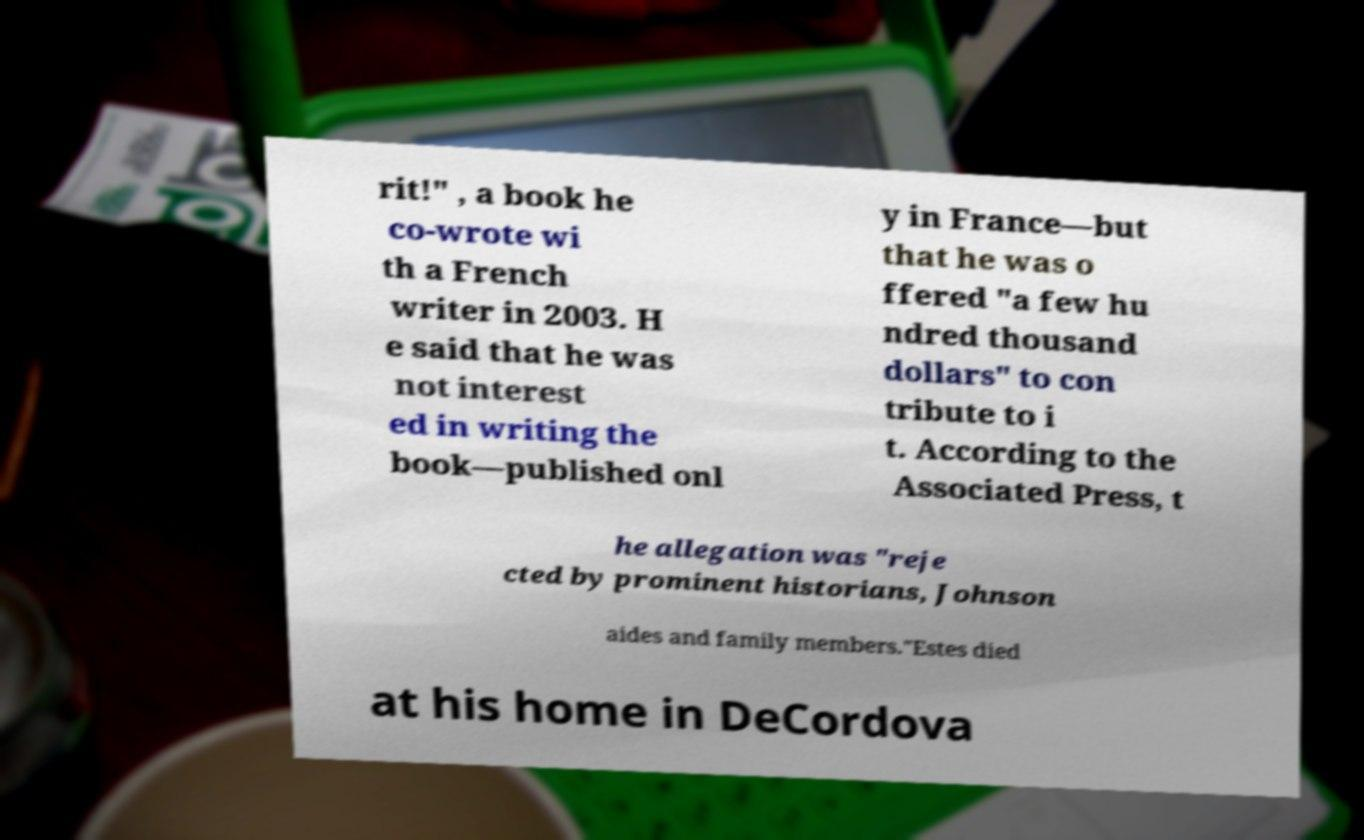For documentation purposes, I need the text within this image transcribed. Could you provide that? rit!" , a book he co-wrote wi th a French writer in 2003. H e said that he was not interest ed in writing the book—published onl y in France—but that he was o ffered "a few hu ndred thousand dollars" to con tribute to i t. According to the Associated Press, t he allegation was "reje cted by prominent historians, Johnson aides and family members."Estes died at his home in DeCordova 